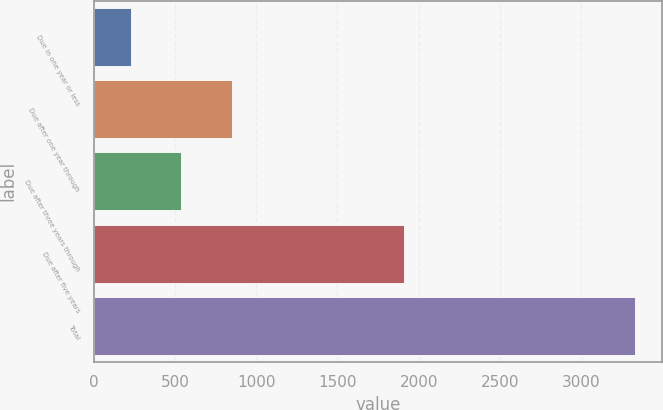Convert chart to OTSL. <chart><loc_0><loc_0><loc_500><loc_500><bar_chart><fcel>Due in one year or less<fcel>Due after one year through<fcel>Due after three years through<fcel>Due after five years<fcel>Total<nl><fcel>230.9<fcel>850.48<fcel>540.69<fcel>1906.8<fcel>3328.8<nl></chart> 